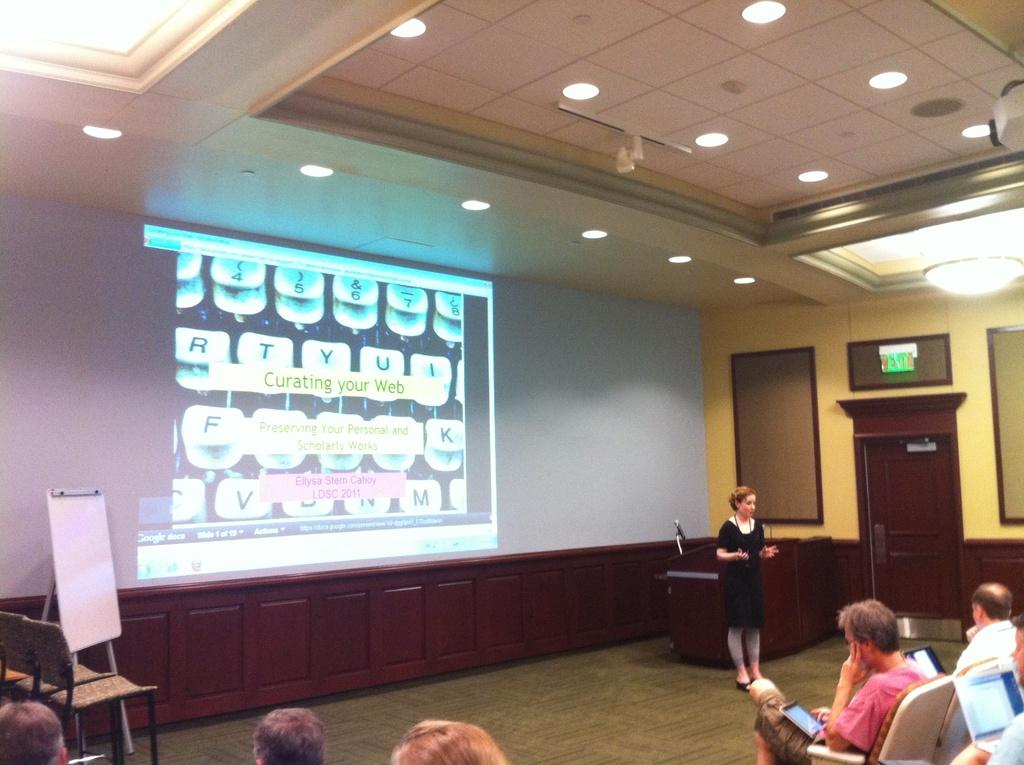<image>
Present a compact description of the photo's key features. A green lighted exit sign is above the door to the right. 